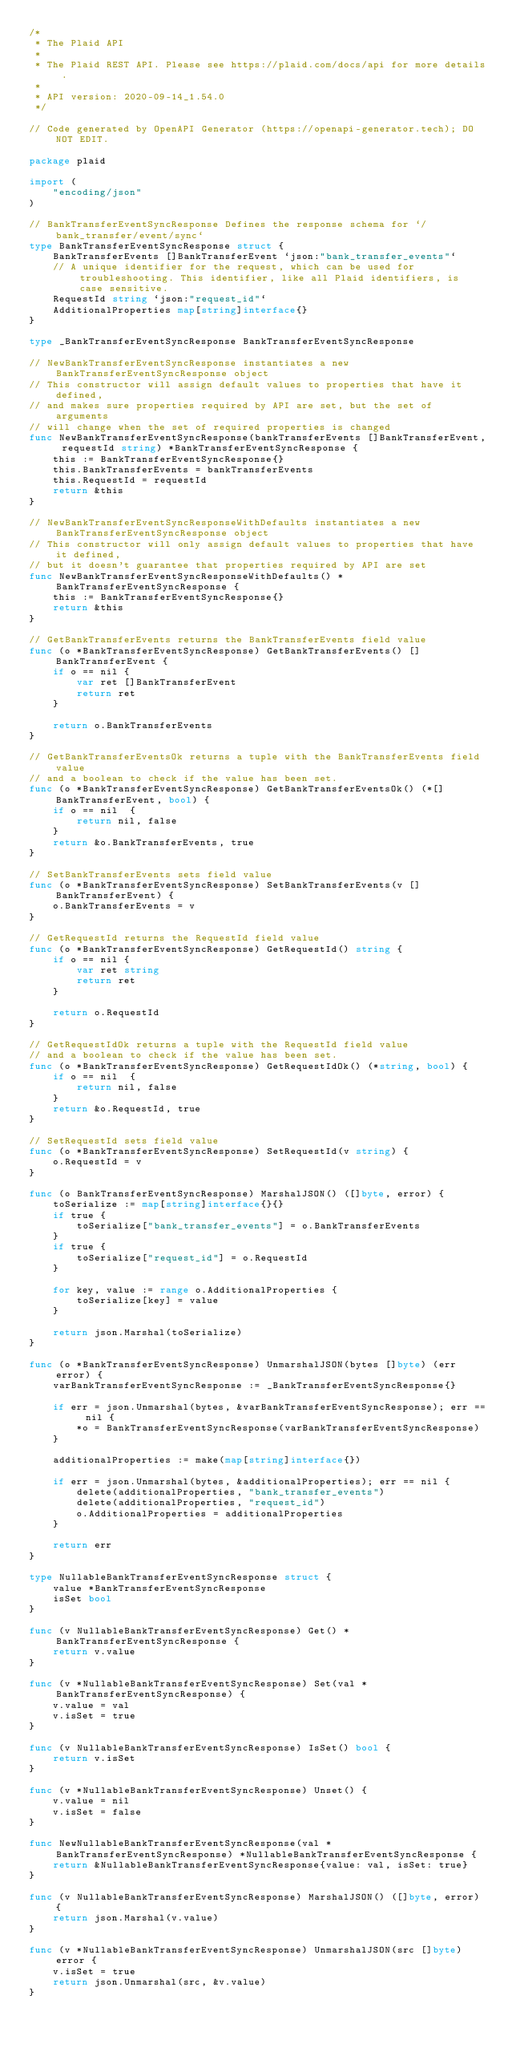<code> <loc_0><loc_0><loc_500><loc_500><_Go_>/*
 * The Plaid API
 *
 * The Plaid REST API. Please see https://plaid.com/docs/api for more details.
 *
 * API version: 2020-09-14_1.54.0
 */

// Code generated by OpenAPI Generator (https://openapi-generator.tech); DO NOT EDIT.

package plaid

import (
	"encoding/json"
)

// BankTransferEventSyncResponse Defines the response schema for `/bank_transfer/event/sync`
type BankTransferEventSyncResponse struct {
	BankTransferEvents []BankTransferEvent `json:"bank_transfer_events"`
	// A unique identifier for the request, which can be used for troubleshooting. This identifier, like all Plaid identifiers, is case sensitive.
	RequestId string `json:"request_id"`
	AdditionalProperties map[string]interface{}
}

type _BankTransferEventSyncResponse BankTransferEventSyncResponse

// NewBankTransferEventSyncResponse instantiates a new BankTransferEventSyncResponse object
// This constructor will assign default values to properties that have it defined,
// and makes sure properties required by API are set, but the set of arguments
// will change when the set of required properties is changed
func NewBankTransferEventSyncResponse(bankTransferEvents []BankTransferEvent, requestId string) *BankTransferEventSyncResponse {
	this := BankTransferEventSyncResponse{}
	this.BankTransferEvents = bankTransferEvents
	this.RequestId = requestId
	return &this
}

// NewBankTransferEventSyncResponseWithDefaults instantiates a new BankTransferEventSyncResponse object
// This constructor will only assign default values to properties that have it defined,
// but it doesn't guarantee that properties required by API are set
func NewBankTransferEventSyncResponseWithDefaults() *BankTransferEventSyncResponse {
	this := BankTransferEventSyncResponse{}
	return &this
}

// GetBankTransferEvents returns the BankTransferEvents field value
func (o *BankTransferEventSyncResponse) GetBankTransferEvents() []BankTransferEvent {
	if o == nil {
		var ret []BankTransferEvent
		return ret
	}

	return o.BankTransferEvents
}

// GetBankTransferEventsOk returns a tuple with the BankTransferEvents field value
// and a boolean to check if the value has been set.
func (o *BankTransferEventSyncResponse) GetBankTransferEventsOk() (*[]BankTransferEvent, bool) {
	if o == nil  {
		return nil, false
	}
	return &o.BankTransferEvents, true
}

// SetBankTransferEvents sets field value
func (o *BankTransferEventSyncResponse) SetBankTransferEvents(v []BankTransferEvent) {
	o.BankTransferEvents = v
}

// GetRequestId returns the RequestId field value
func (o *BankTransferEventSyncResponse) GetRequestId() string {
	if o == nil {
		var ret string
		return ret
	}

	return o.RequestId
}

// GetRequestIdOk returns a tuple with the RequestId field value
// and a boolean to check if the value has been set.
func (o *BankTransferEventSyncResponse) GetRequestIdOk() (*string, bool) {
	if o == nil  {
		return nil, false
	}
	return &o.RequestId, true
}

// SetRequestId sets field value
func (o *BankTransferEventSyncResponse) SetRequestId(v string) {
	o.RequestId = v
}

func (o BankTransferEventSyncResponse) MarshalJSON() ([]byte, error) {
	toSerialize := map[string]interface{}{}
	if true {
		toSerialize["bank_transfer_events"] = o.BankTransferEvents
	}
	if true {
		toSerialize["request_id"] = o.RequestId
	}

	for key, value := range o.AdditionalProperties {
		toSerialize[key] = value
	}

	return json.Marshal(toSerialize)
}

func (o *BankTransferEventSyncResponse) UnmarshalJSON(bytes []byte) (err error) {
	varBankTransferEventSyncResponse := _BankTransferEventSyncResponse{}

	if err = json.Unmarshal(bytes, &varBankTransferEventSyncResponse); err == nil {
		*o = BankTransferEventSyncResponse(varBankTransferEventSyncResponse)
	}

	additionalProperties := make(map[string]interface{})

	if err = json.Unmarshal(bytes, &additionalProperties); err == nil {
		delete(additionalProperties, "bank_transfer_events")
		delete(additionalProperties, "request_id")
		o.AdditionalProperties = additionalProperties
	}

	return err
}

type NullableBankTransferEventSyncResponse struct {
	value *BankTransferEventSyncResponse
	isSet bool
}

func (v NullableBankTransferEventSyncResponse) Get() *BankTransferEventSyncResponse {
	return v.value
}

func (v *NullableBankTransferEventSyncResponse) Set(val *BankTransferEventSyncResponse) {
	v.value = val
	v.isSet = true
}

func (v NullableBankTransferEventSyncResponse) IsSet() bool {
	return v.isSet
}

func (v *NullableBankTransferEventSyncResponse) Unset() {
	v.value = nil
	v.isSet = false
}

func NewNullableBankTransferEventSyncResponse(val *BankTransferEventSyncResponse) *NullableBankTransferEventSyncResponse {
	return &NullableBankTransferEventSyncResponse{value: val, isSet: true}
}

func (v NullableBankTransferEventSyncResponse) MarshalJSON() ([]byte, error) {
	return json.Marshal(v.value)
}

func (v *NullableBankTransferEventSyncResponse) UnmarshalJSON(src []byte) error {
	v.isSet = true
	return json.Unmarshal(src, &v.value)
}


</code> 